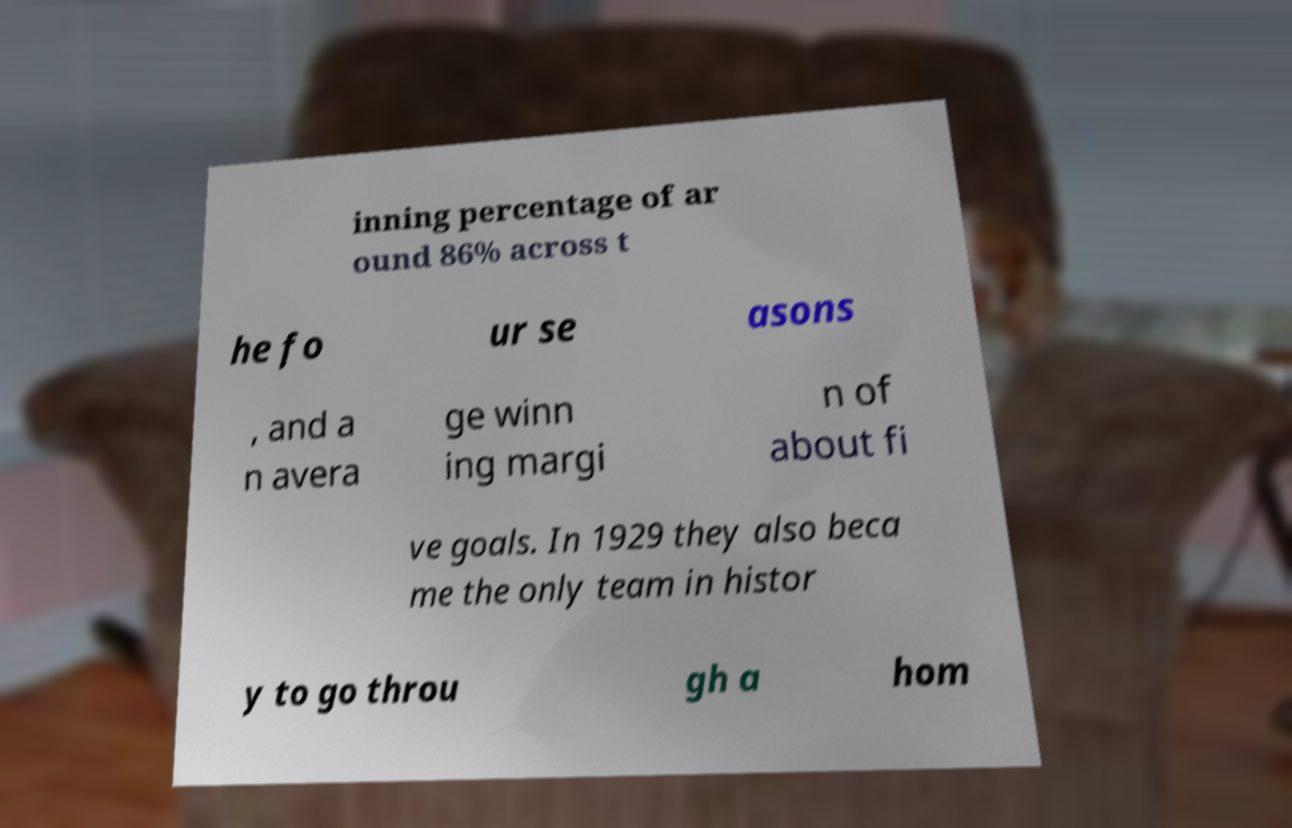There's text embedded in this image that I need extracted. Can you transcribe it verbatim? inning percentage of ar ound 86% across t he fo ur se asons , and a n avera ge winn ing margi n of about fi ve goals. In 1929 they also beca me the only team in histor y to go throu gh a hom 